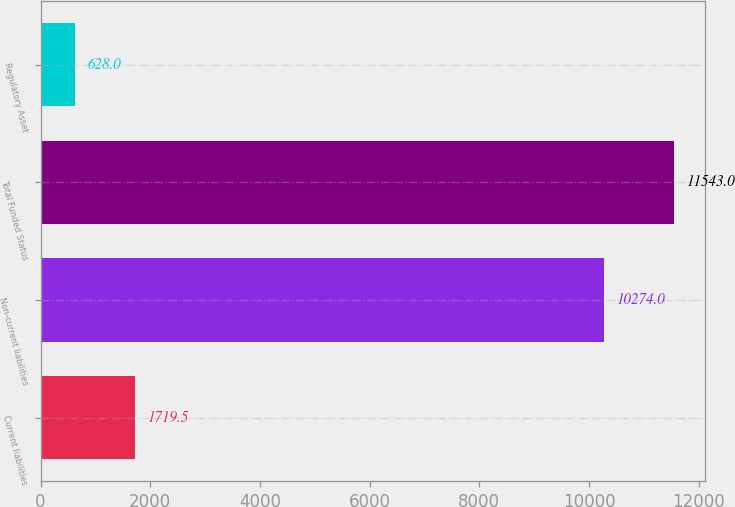Convert chart. <chart><loc_0><loc_0><loc_500><loc_500><bar_chart><fcel>Current liabilities<fcel>Non-current liabilities<fcel>Total Funded Status<fcel>Regulatory Asset<nl><fcel>1719.5<fcel>10274<fcel>11543<fcel>628<nl></chart> 